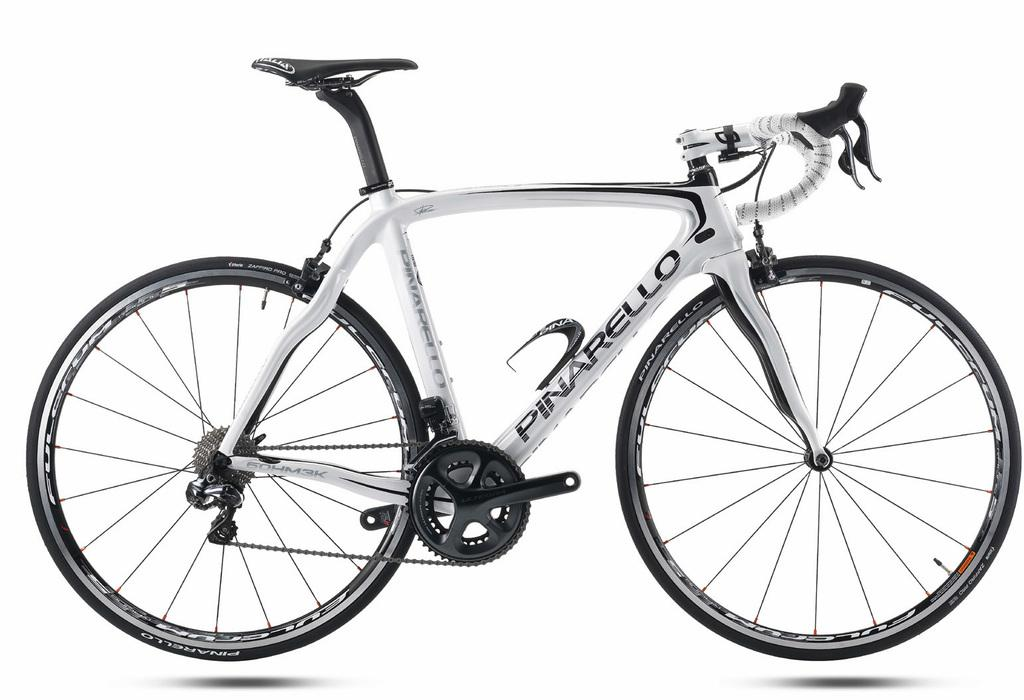What is the main object in the picture? There is a bicycle in the picture. Can you describe any text or writing on the bicycle? Yes, there is something written on the bicycle. What color is the background of the image? The background of the image is white in color. What type of mint can be seen growing near the bicycle in the image? There is no mint present in the image; it only features a bicycle and a white background. 